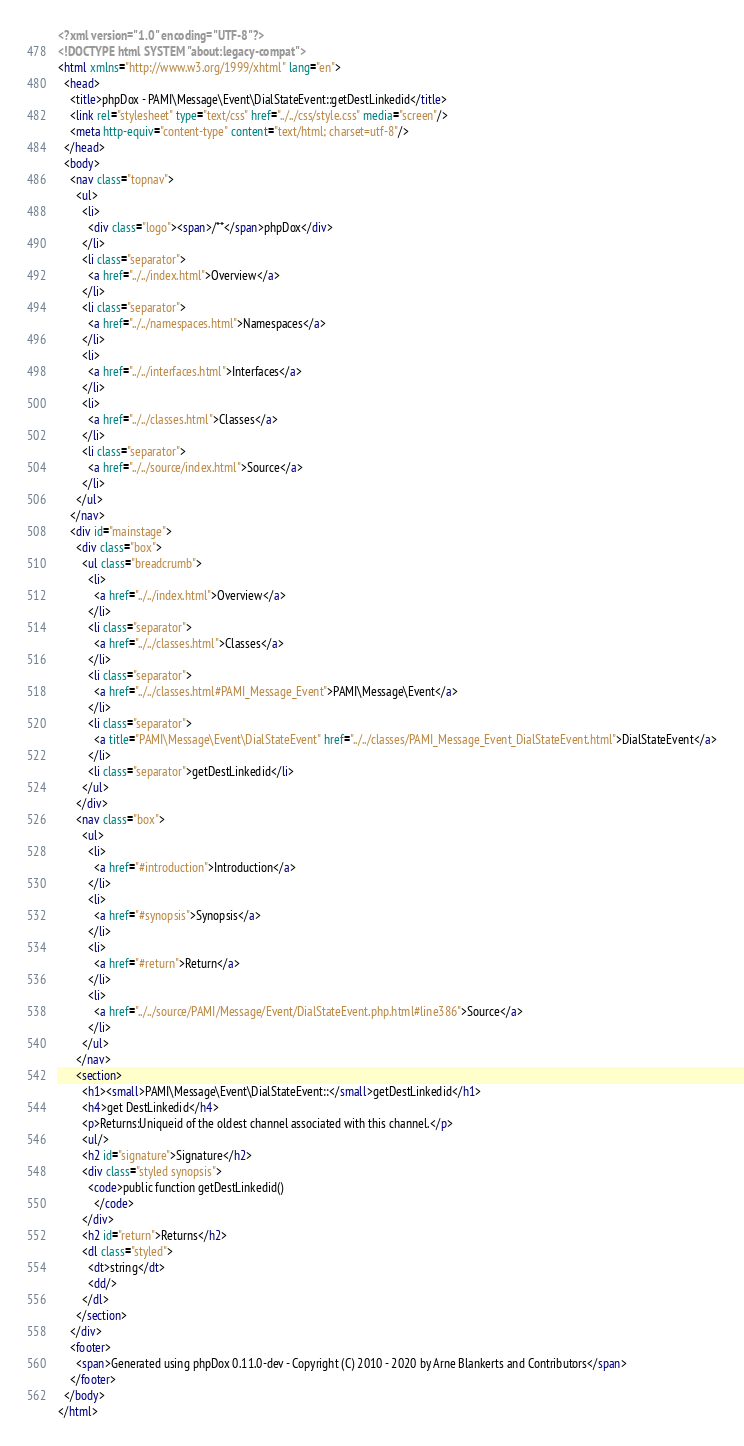Convert code to text. <code><loc_0><loc_0><loc_500><loc_500><_HTML_><?xml version="1.0" encoding="UTF-8"?>
<!DOCTYPE html SYSTEM "about:legacy-compat">
<html xmlns="http://www.w3.org/1999/xhtml" lang="en">
  <head>
    <title>phpDox - PAMI\Message\Event\DialStateEvent::getDestLinkedid</title>
    <link rel="stylesheet" type="text/css" href="../../css/style.css" media="screen"/>
    <meta http-equiv="content-type" content="text/html; charset=utf-8"/>
  </head>
  <body>
    <nav class="topnav">
      <ul>
        <li>
          <div class="logo"><span>/**</span>phpDox</div>
        </li>
        <li class="separator">
          <a href="../../index.html">Overview</a>
        </li>
        <li class="separator">
          <a href="../../namespaces.html">Namespaces</a>
        </li>
        <li>
          <a href="../../interfaces.html">Interfaces</a>
        </li>
        <li>
          <a href="../../classes.html">Classes</a>
        </li>
        <li class="separator">
          <a href="../../source/index.html">Source</a>
        </li>
      </ul>
    </nav>
    <div id="mainstage">
      <div class="box">
        <ul class="breadcrumb">
          <li>
            <a href="../../index.html">Overview</a>
          </li>
          <li class="separator">
            <a href="../../classes.html">Classes</a>
          </li>
          <li class="separator">
            <a href="../../classes.html#PAMI_Message_Event">PAMI\Message\Event</a>
          </li>
          <li class="separator">
            <a title="PAMI\Message\Event\DialStateEvent" href="../../classes/PAMI_Message_Event_DialStateEvent.html">DialStateEvent</a>
          </li>
          <li class="separator">getDestLinkedid</li>
        </ul>
      </div>
      <nav class="box">
        <ul>
          <li>
            <a href="#introduction">Introduction</a>
          </li>
          <li>
            <a href="#synopsis">Synopsis</a>
          </li>
          <li>
            <a href="#return">Return</a>
          </li>
          <li>
            <a href="../../source/PAMI/Message/Event/DialStateEvent.php.html#line386">Source</a>
          </li>
        </ul>
      </nav>
      <section>
        <h1><small>PAMI\Message\Event\DialStateEvent::</small>getDestLinkedid</h1>
        <h4>get DestLinkedid</h4>
        <p>Returns:Uniqueid of the oldest channel associated with this channel.</p>
        <ul/>
        <h2 id="signature">Signature</h2>
        <div class="styled synopsis">
          <code>public function getDestLinkedid()
            </code>
        </div>
        <h2 id="return">Returns</h2>
        <dl class="styled">
          <dt>string</dt>
          <dd/>
        </dl>
      </section>
    </div>
    <footer>
      <span>Generated using phpDox 0.11.0-dev - Copyright (C) 2010 - 2020 by Arne Blankerts and Contributors</span>
    </footer>
  </body>
</html>
</code> 